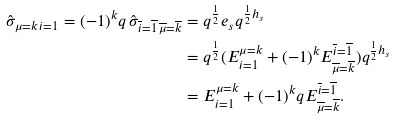Convert formula to latex. <formula><loc_0><loc_0><loc_500><loc_500>\hat { \sigma } _ { \mu = k \, i = 1 } = ( - 1 ) ^ { k } q \, \hat { \sigma } _ { \overline { i } = \overline { 1 } \, \overline { \mu } = \overline { k } } & = q ^ { \frac { 1 } { 2 } } e _ { s } q ^ { \frac { 1 } { 2 } h _ { s } } \\ & = q ^ { \frac { 1 } { 2 } } ( E ^ { \mu = k } _ { i = 1 } + ( - 1 ) ^ { k } E ^ { \overline { i } = \overline { 1 } } _ { \overline { \mu } = \overline { k } } ) q ^ { \frac { 1 } { 2 } h _ { s } } \\ & = E ^ { \mu = k } _ { i = 1 } + ( - 1 ) ^ { k } q E ^ { \overline { i } = \overline { 1 } } _ { \overline { \mu } = \overline { k } } .</formula> 